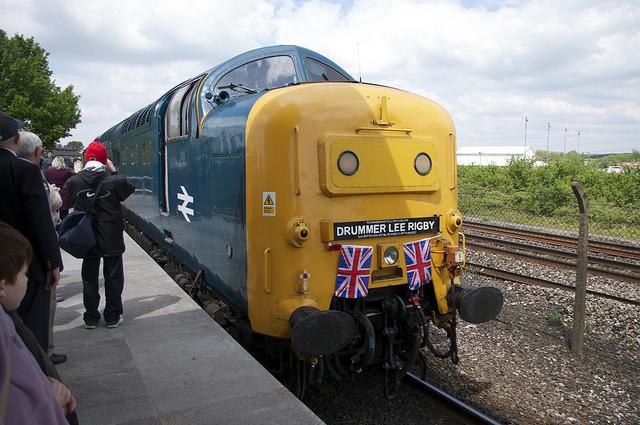What color is the front of the train?
Concise answer only. Yellow. What are the three words printed on the front of the train?
Quick response, please. Drummer lee rigby. Are these people waiting to get on the train?
Quick response, please. Yes. 